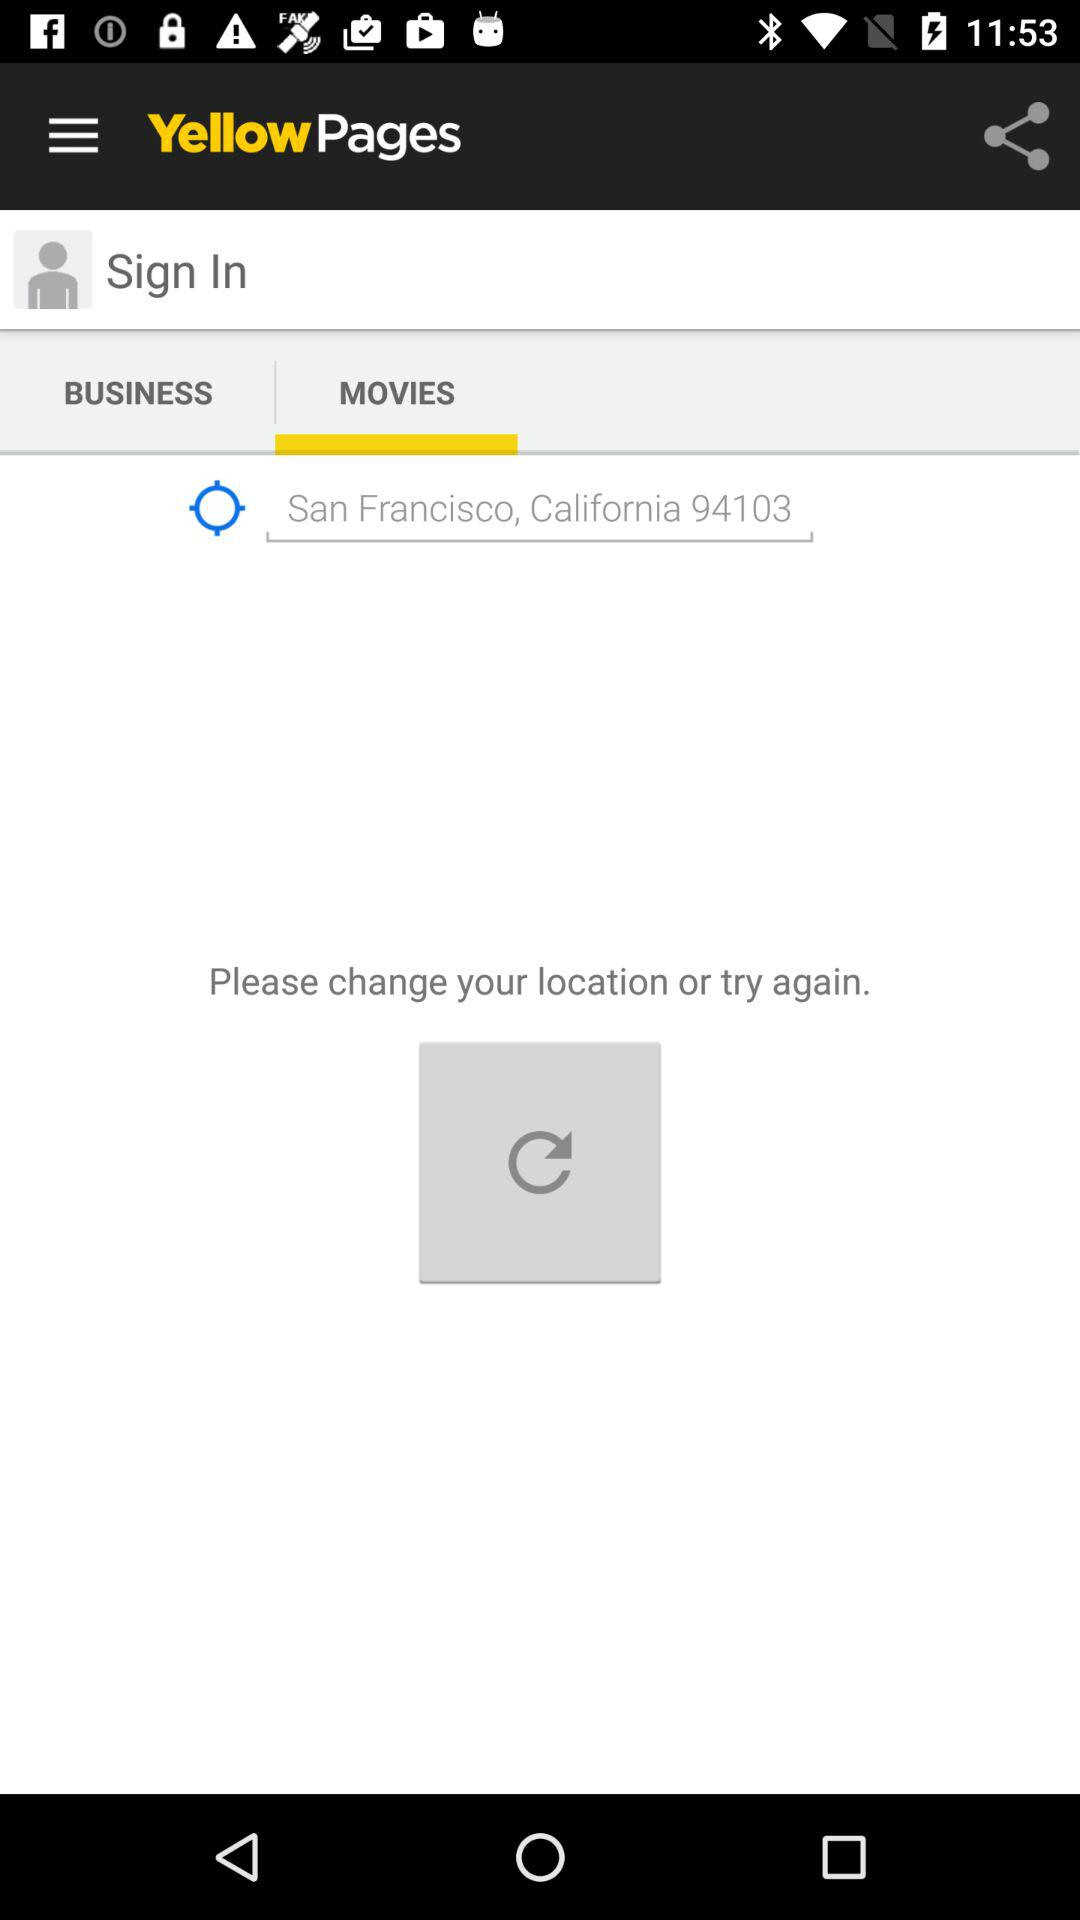What is the entered location? The entered location is San Francisco, California 94103. 